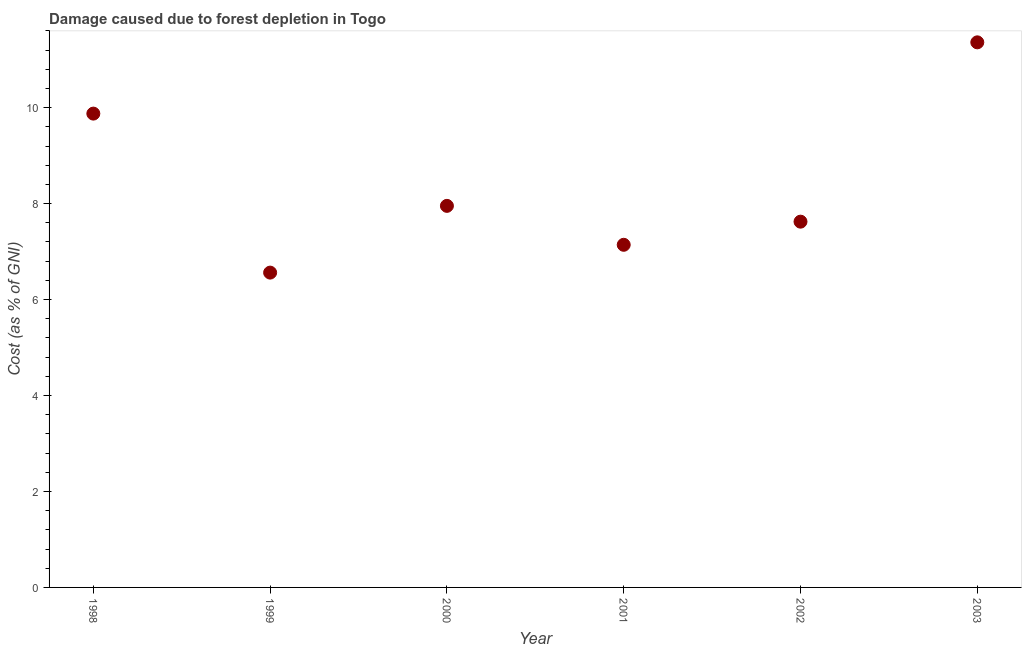What is the damage caused due to forest depletion in 2003?
Ensure brevity in your answer.  11.36. Across all years, what is the maximum damage caused due to forest depletion?
Offer a very short reply. 11.36. Across all years, what is the minimum damage caused due to forest depletion?
Provide a succinct answer. 6.56. In which year was the damage caused due to forest depletion minimum?
Provide a succinct answer. 1999. What is the sum of the damage caused due to forest depletion?
Ensure brevity in your answer.  50.51. What is the difference between the damage caused due to forest depletion in 2000 and 2002?
Your answer should be compact. 0.33. What is the average damage caused due to forest depletion per year?
Provide a short and direct response. 8.42. What is the median damage caused due to forest depletion?
Offer a very short reply. 7.79. In how many years, is the damage caused due to forest depletion greater than 2.8 %?
Give a very brief answer. 6. What is the ratio of the damage caused due to forest depletion in 2000 to that in 2001?
Your answer should be very brief. 1.11. Is the damage caused due to forest depletion in 1998 less than that in 2002?
Your response must be concise. No. What is the difference between the highest and the second highest damage caused due to forest depletion?
Your answer should be compact. 1.49. Is the sum of the damage caused due to forest depletion in 2001 and 2002 greater than the maximum damage caused due to forest depletion across all years?
Your response must be concise. Yes. What is the difference between the highest and the lowest damage caused due to forest depletion?
Give a very brief answer. 4.8. Does the damage caused due to forest depletion monotonically increase over the years?
Offer a terse response. No. How many years are there in the graph?
Provide a succinct answer. 6. Does the graph contain grids?
Your answer should be compact. No. What is the title of the graph?
Offer a very short reply. Damage caused due to forest depletion in Togo. What is the label or title of the Y-axis?
Make the answer very short. Cost (as % of GNI). What is the Cost (as % of GNI) in 1998?
Make the answer very short. 9.88. What is the Cost (as % of GNI) in 1999?
Make the answer very short. 6.56. What is the Cost (as % of GNI) in 2000?
Your response must be concise. 7.95. What is the Cost (as % of GNI) in 2001?
Provide a short and direct response. 7.14. What is the Cost (as % of GNI) in 2002?
Your response must be concise. 7.62. What is the Cost (as % of GNI) in 2003?
Your answer should be compact. 11.36. What is the difference between the Cost (as % of GNI) in 1998 and 1999?
Provide a short and direct response. 3.31. What is the difference between the Cost (as % of GNI) in 1998 and 2000?
Your response must be concise. 1.92. What is the difference between the Cost (as % of GNI) in 1998 and 2001?
Your response must be concise. 2.73. What is the difference between the Cost (as % of GNI) in 1998 and 2002?
Your response must be concise. 2.25. What is the difference between the Cost (as % of GNI) in 1998 and 2003?
Give a very brief answer. -1.49. What is the difference between the Cost (as % of GNI) in 1999 and 2000?
Ensure brevity in your answer.  -1.39. What is the difference between the Cost (as % of GNI) in 1999 and 2001?
Your answer should be very brief. -0.58. What is the difference between the Cost (as % of GNI) in 1999 and 2002?
Your answer should be compact. -1.06. What is the difference between the Cost (as % of GNI) in 1999 and 2003?
Offer a terse response. -4.8. What is the difference between the Cost (as % of GNI) in 2000 and 2001?
Your answer should be compact. 0.81. What is the difference between the Cost (as % of GNI) in 2000 and 2002?
Your response must be concise. 0.33. What is the difference between the Cost (as % of GNI) in 2000 and 2003?
Give a very brief answer. -3.41. What is the difference between the Cost (as % of GNI) in 2001 and 2002?
Give a very brief answer. -0.48. What is the difference between the Cost (as % of GNI) in 2001 and 2003?
Offer a very short reply. -4.22. What is the difference between the Cost (as % of GNI) in 2002 and 2003?
Offer a terse response. -3.74. What is the ratio of the Cost (as % of GNI) in 1998 to that in 1999?
Provide a succinct answer. 1.5. What is the ratio of the Cost (as % of GNI) in 1998 to that in 2000?
Provide a succinct answer. 1.24. What is the ratio of the Cost (as % of GNI) in 1998 to that in 2001?
Your answer should be compact. 1.38. What is the ratio of the Cost (as % of GNI) in 1998 to that in 2002?
Offer a terse response. 1.29. What is the ratio of the Cost (as % of GNI) in 1998 to that in 2003?
Make the answer very short. 0.87. What is the ratio of the Cost (as % of GNI) in 1999 to that in 2000?
Keep it short and to the point. 0.82. What is the ratio of the Cost (as % of GNI) in 1999 to that in 2001?
Your response must be concise. 0.92. What is the ratio of the Cost (as % of GNI) in 1999 to that in 2002?
Offer a very short reply. 0.86. What is the ratio of the Cost (as % of GNI) in 1999 to that in 2003?
Keep it short and to the point. 0.58. What is the ratio of the Cost (as % of GNI) in 2000 to that in 2001?
Keep it short and to the point. 1.11. What is the ratio of the Cost (as % of GNI) in 2000 to that in 2002?
Offer a very short reply. 1.04. What is the ratio of the Cost (as % of GNI) in 2001 to that in 2002?
Offer a terse response. 0.94. What is the ratio of the Cost (as % of GNI) in 2001 to that in 2003?
Ensure brevity in your answer.  0.63. What is the ratio of the Cost (as % of GNI) in 2002 to that in 2003?
Keep it short and to the point. 0.67. 